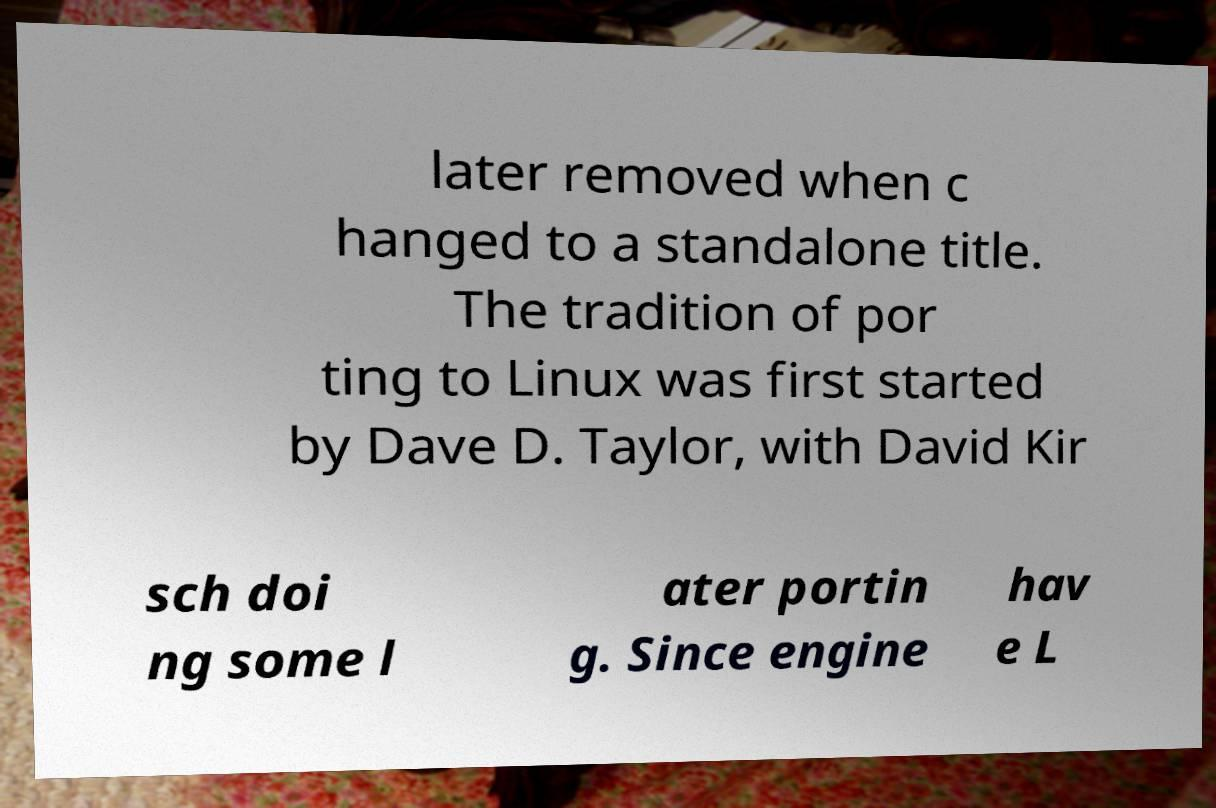Can you accurately transcribe the text from the provided image for me? later removed when c hanged to a standalone title. The tradition of por ting to Linux was first started by Dave D. Taylor, with David Kir sch doi ng some l ater portin g. Since engine hav e L 